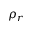<formula> <loc_0><loc_0><loc_500><loc_500>\rho _ { r }</formula> 